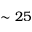Convert formula to latex. <formula><loc_0><loc_0><loc_500><loc_500>\sim 2 5</formula> 